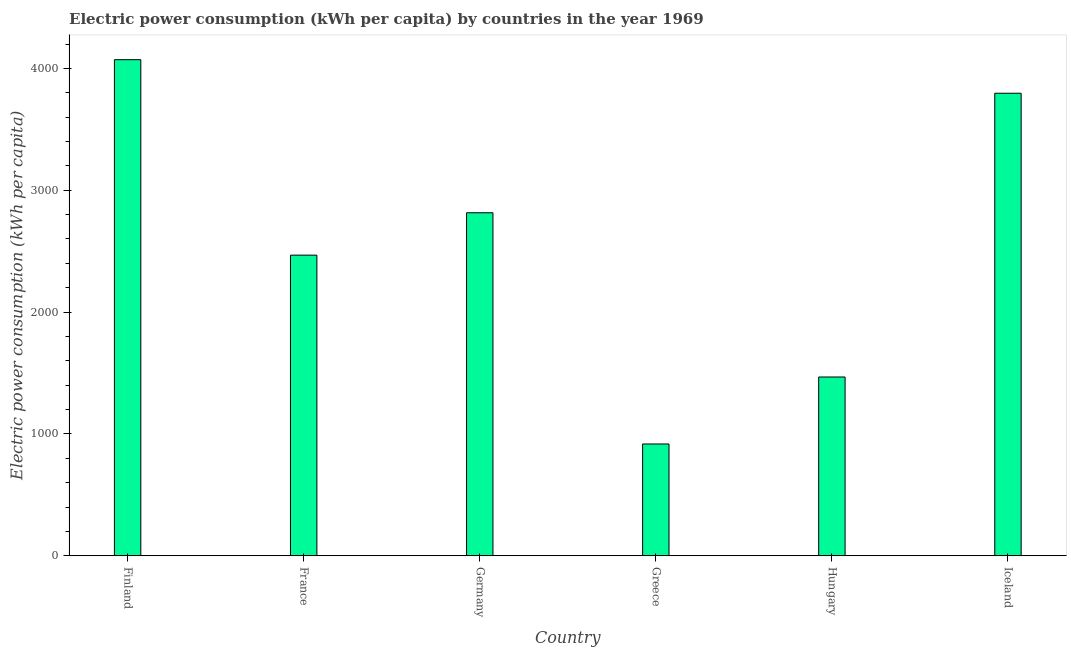What is the title of the graph?
Your response must be concise. Electric power consumption (kWh per capita) by countries in the year 1969. What is the label or title of the X-axis?
Your answer should be very brief. Country. What is the label or title of the Y-axis?
Provide a short and direct response. Electric power consumption (kWh per capita). What is the electric power consumption in Finland?
Give a very brief answer. 4071.56. Across all countries, what is the maximum electric power consumption?
Make the answer very short. 4071.56. Across all countries, what is the minimum electric power consumption?
Your answer should be very brief. 917.61. What is the sum of the electric power consumption?
Provide a succinct answer. 1.55e+04. What is the difference between the electric power consumption in Hungary and Iceland?
Provide a short and direct response. -2328.69. What is the average electric power consumption per country?
Your response must be concise. 2589.19. What is the median electric power consumption?
Offer a very short reply. 2641.27. What is the ratio of the electric power consumption in Finland to that in Germany?
Make the answer very short. 1.45. Is the electric power consumption in France less than that in Hungary?
Your answer should be very brief. No. Is the difference between the electric power consumption in France and Hungary greater than the difference between any two countries?
Your answer should be very brief. No. What is the difference between the highest and the second highest electric power consumption?
Make the answer very short. 275.5. What is the difference between the highest and the lowest electric power consumption?
Make the answer very short. 3153.94. In how many countries, is the electric power consumption greater than the average electric power consumption taken over all countries?
Offer a very short reply. 3. Are all the bars in the graph horizontal?
Provide a short and direct response. No. Are the values on the major ticks of Y-axis written in scientific E-notation?
Your answer should be very brief. No. What is the Electric power consumption (kWh per capita) of Finland?
Offer a very short reply. 4071.56. What is the Electric power consumption (kWh per capita) of France?
Your answer should be very brief. 2467.32. What is the Electric power consumption (kWh per capita) of Germany?
Make the answer very short. 2815.22. What is the Electric power consumption (kWh per capita) of Greece?
Make the answer very short. 917.61. What is the Electric power consumption (kWh per capita) in Hungary?
Your response must be concise. 1467.37. What is the Electric power consumption (kWh per capita) of Iceland?
Give a very brief answer. 3796.06. What is the difference between the Electric power consumption (kWh per capita) in Finland and France?
Your answer should be very brief. 1604.24. What is the difference between the Electric power consumption (kWh per capita) in Finland and Germany?
Your response must be concise. 1256.33. What is the difference between the Electric power consumption (kWh per capita) in Finland and Greece?
Make the answer very short. 3153.94. What is the difference between the Electric power consumption (kWh per capita) in Finland and Hungary?
Provide a succinct answer. 2604.19. What is the difference between the Electric power consumption (kWh per capita) in Finland and Iceland?
Offer a terse response. 275.5. What is the difference between the Electric power consumption (kWh per capita) in France and Germany?
Your response must be concise. -347.9. What is the difference between the Electric power consumption (kWh per capita) in France and Greece?
Provide a succinct answer. 1549.71. What is the difference between the Electric power consumption (kWh per capita) in France and Hungary?
Your answer should be compact. 999.95. What is the difference between the Electric power consumption (kWh per capita) in France and Iceland?
Provide a succinct answer. -1328.74. What is the difference between the Electric power consumption (kWh per capita) in Germany and Greece?
Offer a terse response. 1897.61. What is the difference between the Electric power consumption (kWh per capita) in Germany and Hungary?
Offer a very short reply. 1347.85. What is the difference between the Electric power consumption (kWh per capita) in Germany and Iceland?
Keep it short and to the point. -980.83. What is the difference between the Electric power consumption (kWh per capita) in Greece and Hungary?
Ensure brevity in your answer.  -549.75. What is the difference between the Electric power consumption (kWh per capita) in Greece and Iceland?
Offer a terse response. -2878.44. What is the difference between the Electric power consumption (kWh per capita) in Hungary and Iceland?
Your answer should be very brief. -2328.69. What is the ratio of the Electric power consumption (kWh per capita) in Finland to that in France?
Make the answer very short. 1.65. What is the ratio of the Electric power consumption (kWh per capita) in Finland to that in Germany?
Make the answer very short. 1.45. What is the ratio of the Electric power consumption (kWh per capita) in Finland to that in Greece?
Keep it short and to the point. 4.44. What is the ratio of the Electric power consumption (kWh per capita) in Finland to that in Hungary?
Your answer should be very brief. 2.77. What is the ratio of the Electric power consumption (kWh per capita) in Finland to that in Iceland?
Your response must be concise. 1.07. What is the ratio of the Electric power consumption (kWh per capita) in France to that in Germany?
Ensure brevity in your answer.  0.88. What is the ratio of the Electric power consumption (kWh per capita) in France to that in Greece?
Give a very brief answer. 2.69. What is the ratio of the Electric power consumption (kWh per capita) in France to that in Hungary?
Your answer should be compact. 1.68. What is the ratio of the Electric power consumption (kWh per capita) in France to that in Iceland?
Your response must be concise. 0.65. What is the ratio of the Electric power consumption (kWh per capita) in Germany to that in Greece?
Your response must be concise. 3.07. What is the ratio of the Electric power consumption (kWh per capita) in Germany to that in Hungary?
Provide a short and direct response. 1.92. What is the ratio of the Electric power consumption (kWh per capita) in Germany to that in Iceland?
Offer a very short reply. 0.74. What is the ratio of the Electric power consumption (kWh per capita) in Greece to that in Iceland?
Offer a terse response. 0.24. What is the ratio of the Electric power consumption (kWh per capita) in Hungary to that in Iceland?
Offer a terse response. 0.39. 